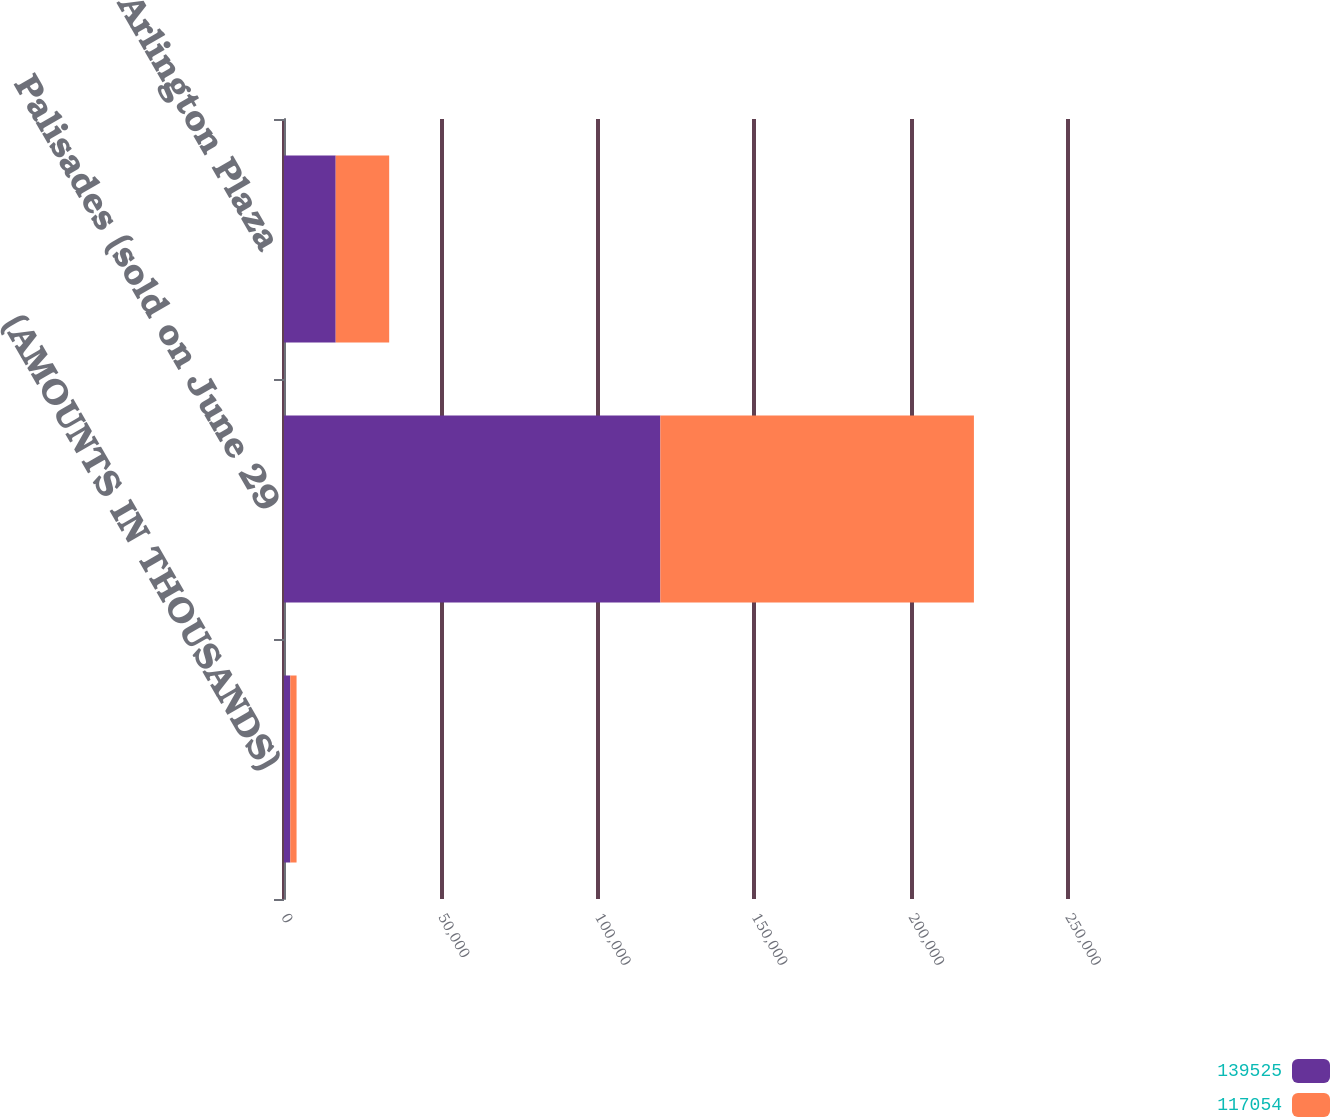<chart> <loc_0><loc_0><loc_500><loc_500><stacked_bar_chart><ecel><fcel>(AMOUNTS IN THOUSANDS)<fcel>Palisades (sold on June 29<fcel>Arlington Plaza<nl><fcel>139525<fcel>2003<fcel>120000<fcel>16487<nl><fcel>117054<fcel>2002<fcel>100000<fcel>17054<nl></chart> 